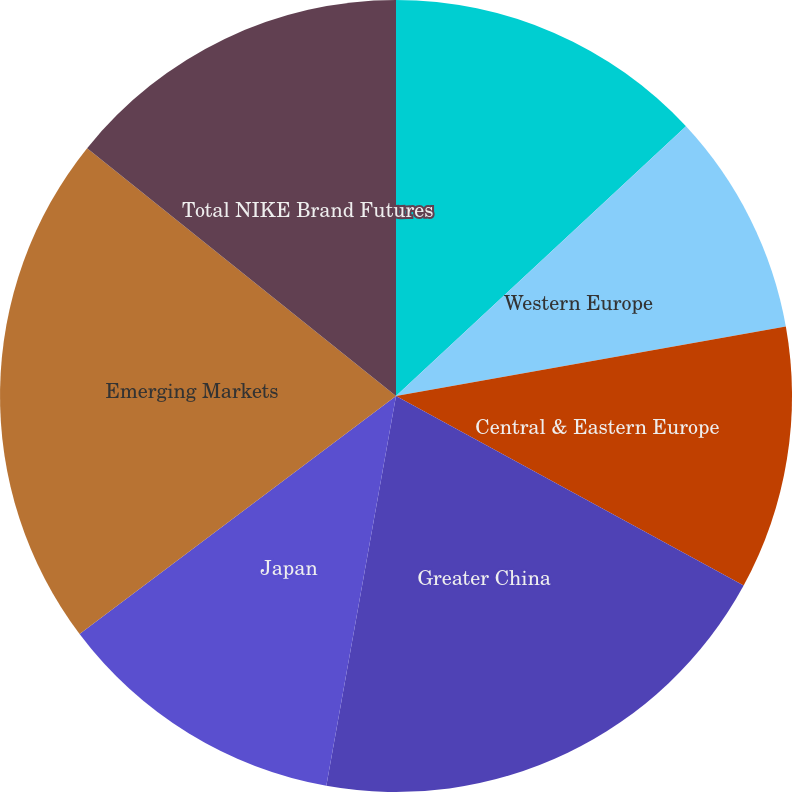Convert chart to OTSL. <chart><loc_0><loc_0><loc_500><loc_500><pie_chart><fcel>North America<fcel>Western Europe<fcel>Central & Eastern Europe<fcel>Greater China<fcel>Japan<fcel>Emerging Markets<fcel>Total NIKE Brand Futures<nl><fcel>13.08%<fcel>9.11%<fcel>10.76%<fcel>19.87%<fcel>11.92%<fcel>21.03%<fcel>14.24%<nl></chart> 